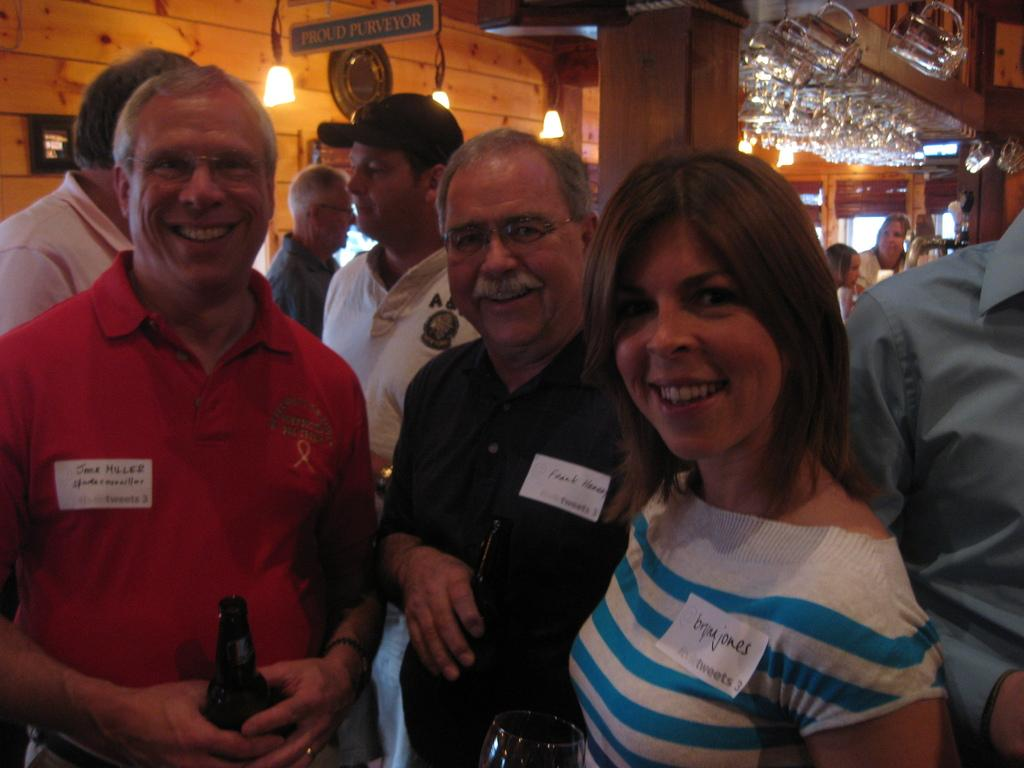What can be seen in the image? There are people standing in the image. What type of structure is visible in the background? There is a wooden pillar in the background of the image. What material is used for the wall in the image? There is a wooden wall in the image. What color is the board in the image? There is a green board in the image. What can provide illumination in the image? There are lights visible in the image. Reasoning: Let's think step by step by step in order to produce the conversation. We start by identifying the main subjects in the image, which are the people standing. Then, we describe the various elements of the background and setting, such as the wooden pillar, wooden wall, green board, and lights. Each question is designed to elicit a specific detail about the image that is known from the provided facts. Absurd Question/Answer: How many debts are sitting on the green board in the image? There are no debts or chains present in the image; it features people, a wooden pillar, a wooden wall, a green board, and lights. What type of nut is being used to secure the wooden wall in the image? There is no mention of nuts or any fastening materials in the image; it features people, a wooden pillar, a wooden wall, a green board, and lights. 